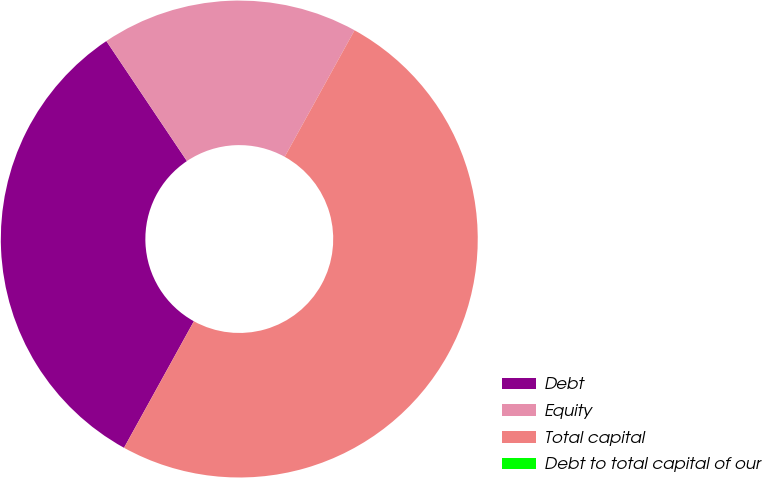Convert chart to OTSL. <chart><loc_0><loc_0><loc_500><loc_500><pie_chart><fcel>Debt<fcel>Equity<fcel>Total capital<fcel>Debt to total capital of our<nl><fcel>32.56%<fcel>17.44%<fcel>50.0%<fcel>0.0%<nl></chart> 